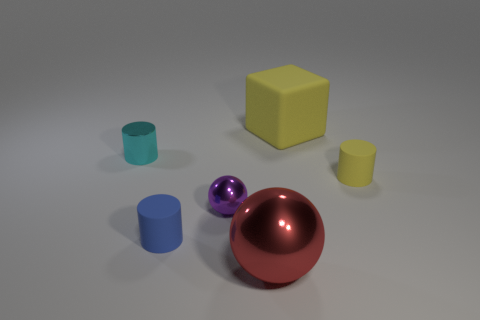Subtract all tiny yellow cylinders. How many cylinders are left? 2 Add 2 big shiny spheres. How many objects exist? 8 Subtract 1 cylinders. How many cylinders are left? 2 Subtract all cubes. How many objects are left? 5 Subtract all gray cylinders. Subtract all blue cubes. How many cylinders are left? 3 Subtract all metallic things. Subtract all small metal balls. How many objects are left? 2 Add 1 blue rubber cylinders. How many blue rubber cylinders are left? 2 Add 5 tiny blue things. How many tiny blue things exist? 6 Subtract 0 purple cylinders. How many objects are left? 6 